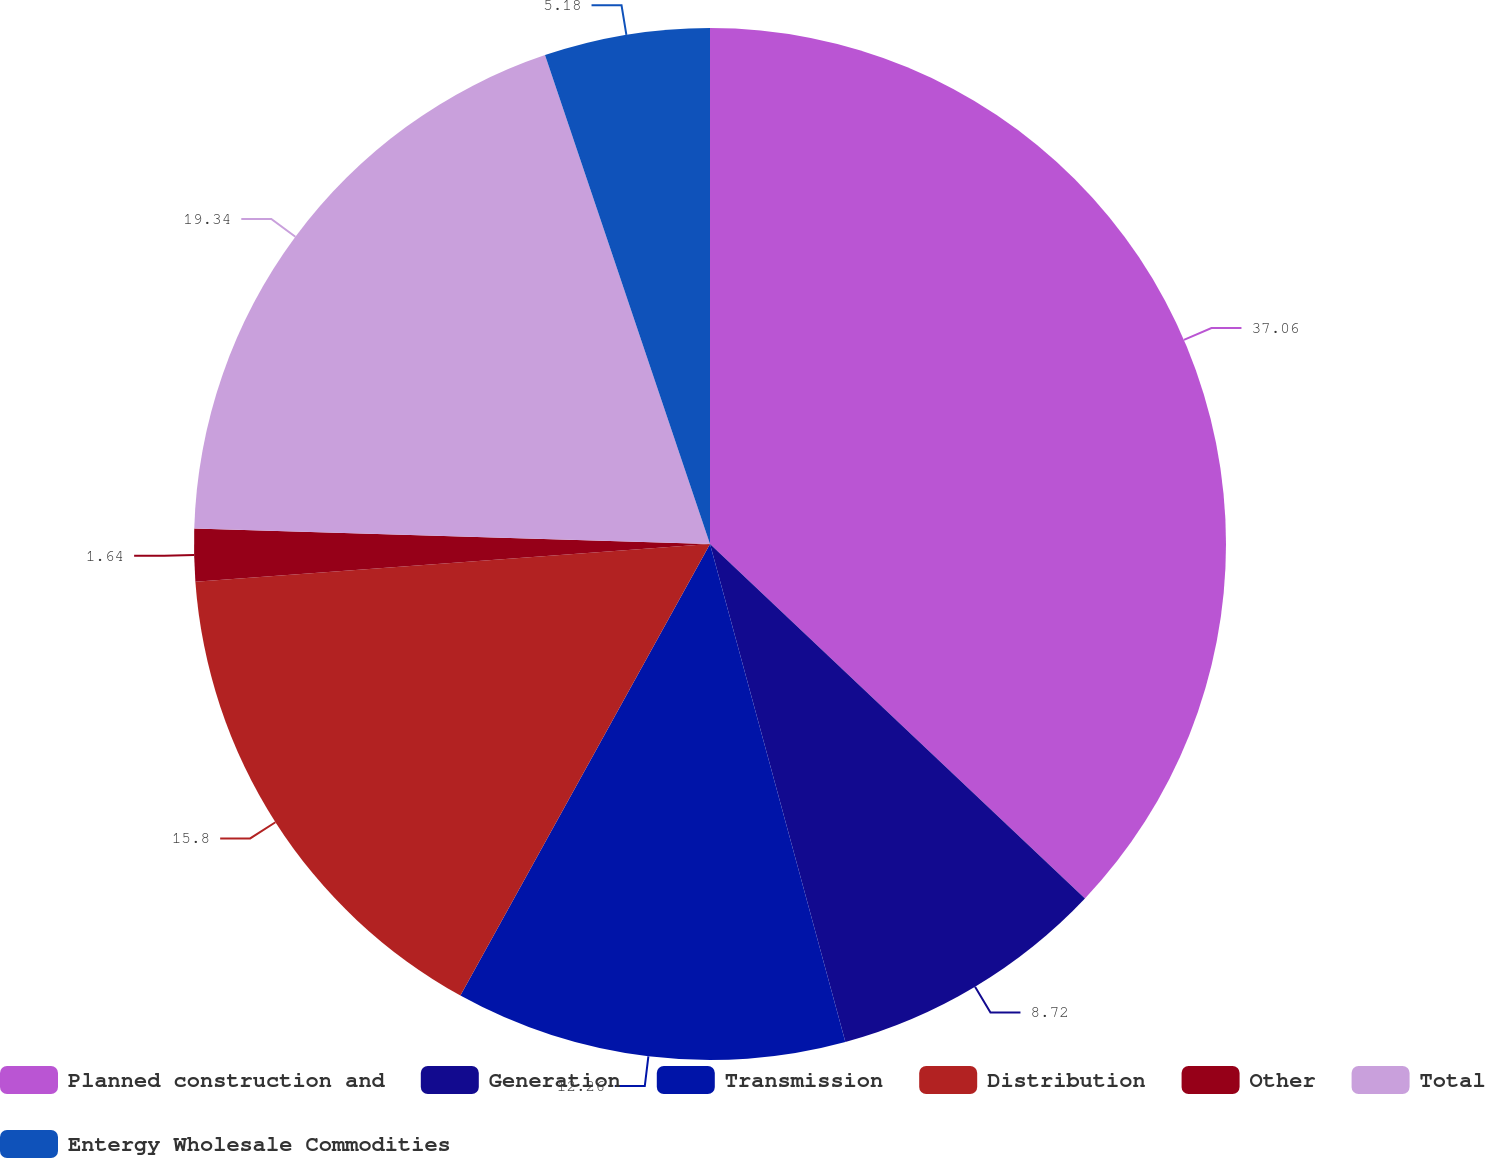Convert chart. <chart><loc_0><loc_0><loc_500><loc_500><pie_chart><fcel>Planned construction and<fcel>Generation<fcel>Transmission<fcel>Distribution<fcel>Other<fcel>Total<fcel>Entergy Wholesale Commodities<nl><fcel>37.05%<fcel>8.72%<fcel>12.26%<fcel>15.8%<fcel>1.64%<fcel>19.34%<fcel>5.18%<nl></chart> 